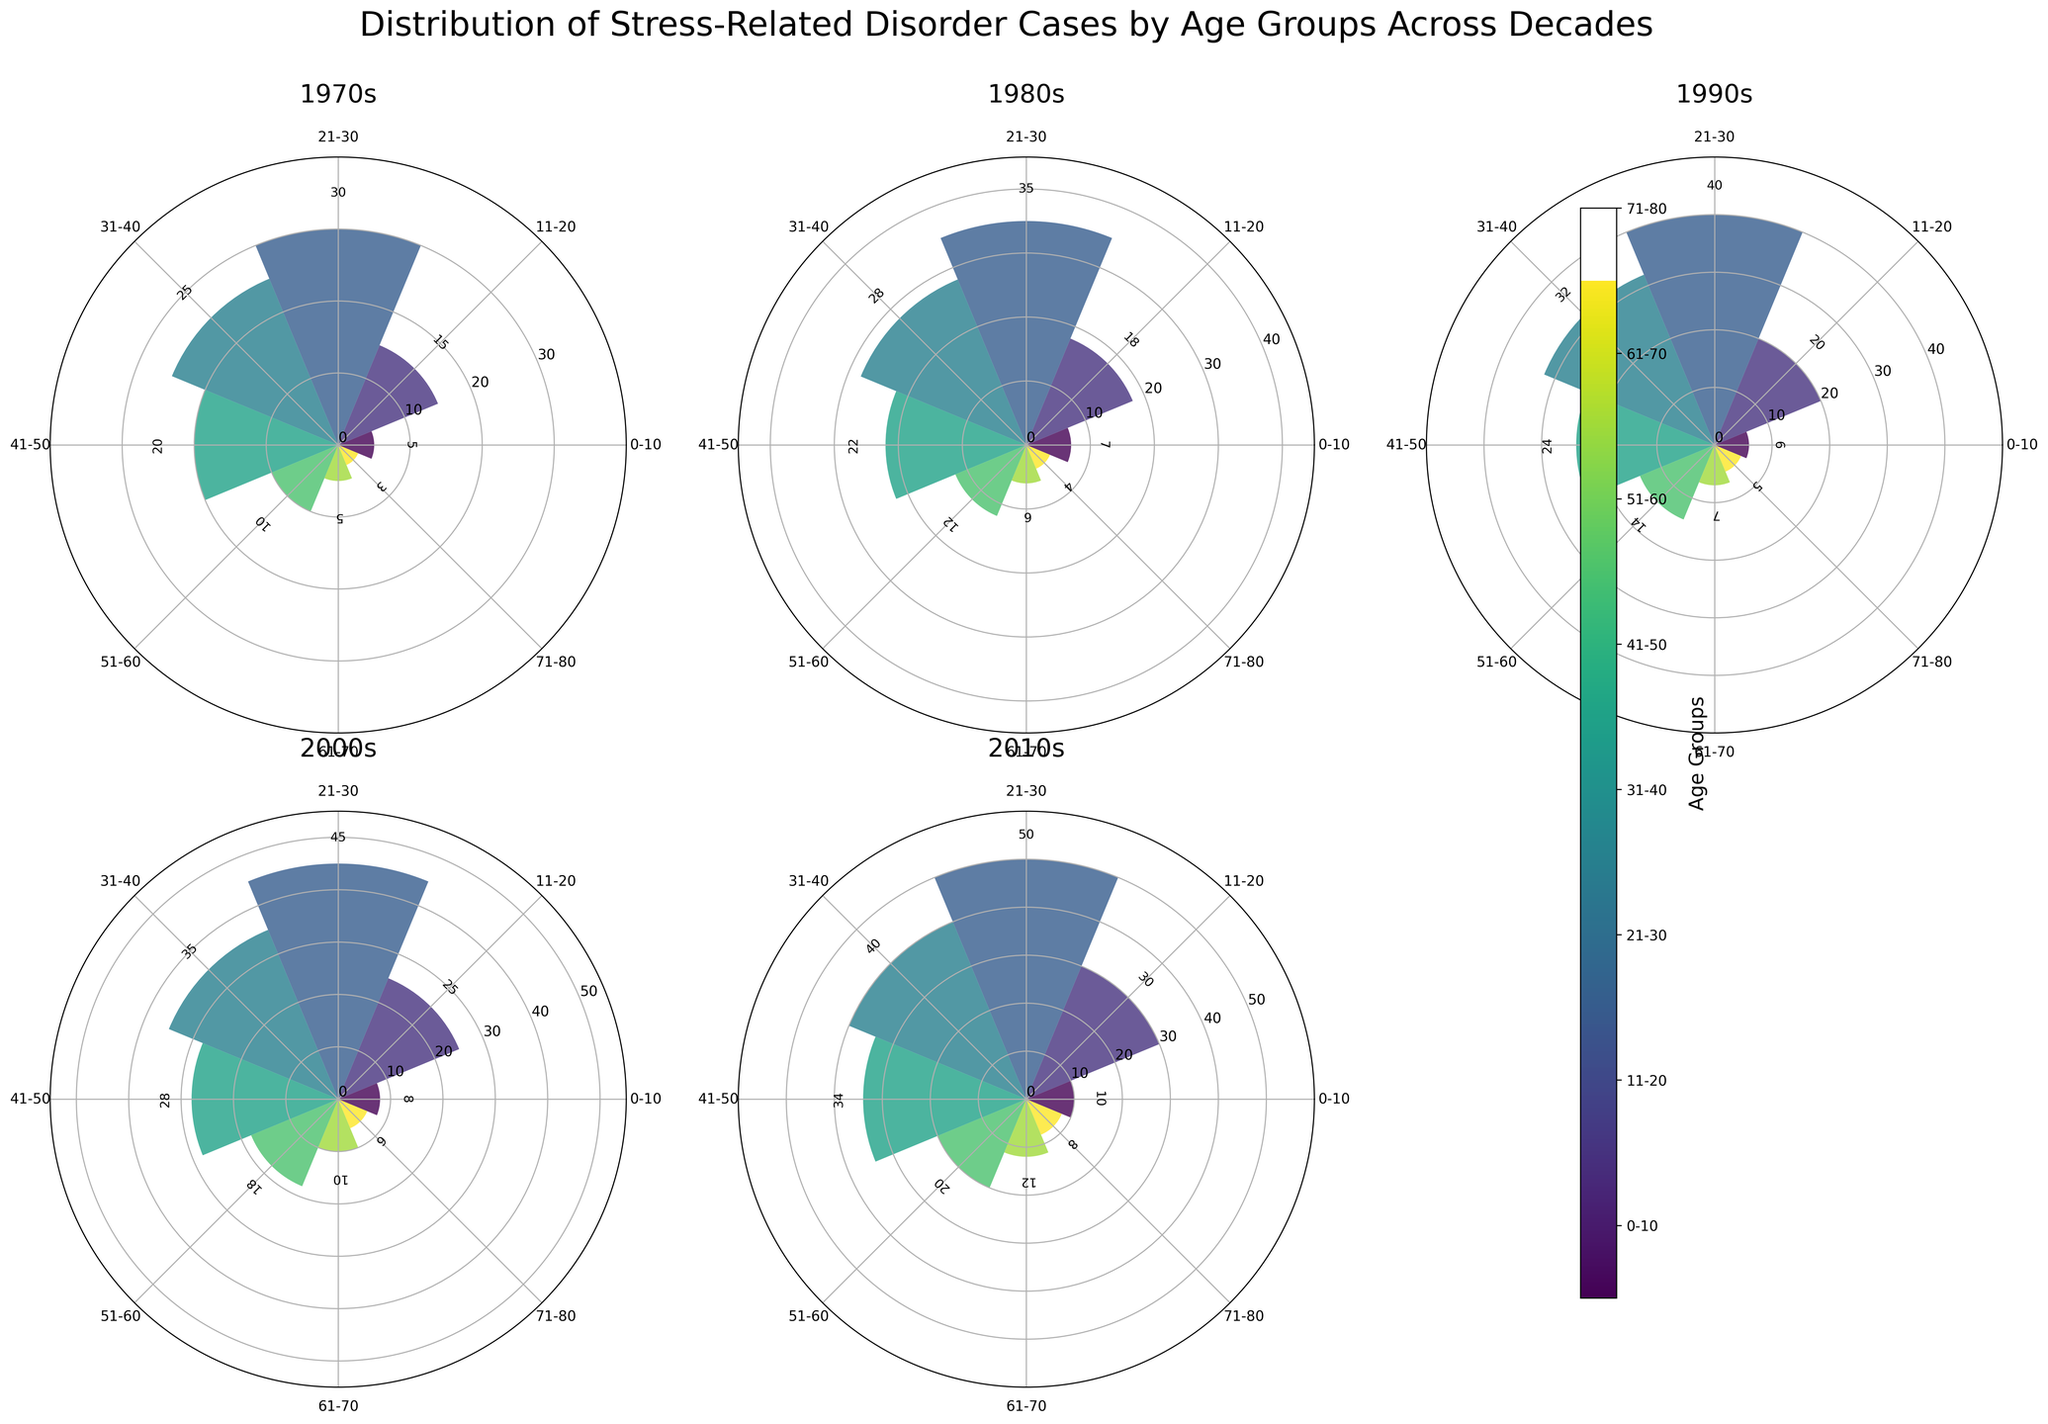What is the title of the figure? The title is usually placed at the top of the figure for easy identification. In this case, it describes the overall content.
Answer: Distribution of Stress-Related Disorder Cases by Age Groups Across Decades What colors are used in the figure to represent different age groups? Colors help differentiate between categories. Here, a gradient from the viridis colormap is utilized.
Answer: Various shades from viridis colormap (e.g., green to purple) Which decade shows the highest number of stress-related disorder cases for the age group 21-30? By comparing the heights of the bars in each subplot for the age group 21-30, we can identify the decade with the highest count.
Answer: 2010s What is the median number of stress-related disorder cases for the age group 31-40 across all decades? First, list the values for 31-40: [25, 28, 32, 35, 40]. Then, sort them and find the middle value.
Answer: 32 How does the distribution of cases in the 2010s compare to the 1970s for the age group 61-70? Comparing the height of the bars in the subplots for these two decades for age group 61-70 will show the difference.
Answer: Higher in the 2010s (12 vs. 5) Which decade exhibits the smallest variation in the number of cases across all age groups? Look at the subplots and identify the decade where the heights of the bars are closest to each other. Variation can be inferred visually by the uniformity of bar heights.
Answer: 1970s In which decade does the age group 11-20 have the fewest number of cases? By comparing the height of the bars corresponding to the age group 11-20 across subplots, we can find the decade with the smallest bar.
Answer: 1970s What was the total number of stress-related disorder cases reported in the 1980s? Sum all the values from the 1980s: 7+18+35+28+22+12+6+4 = 132.
Answer: 132 How does the trend in stress-related cases for the age group 0-10 evolve over the decades? Observe the change in bar heights for the age group 0-10 across the subplots to identify any trends.
Answer: Increases over the decades What does the bar representing the age group 71-80 in the 2000s indicate about the number of cases? Check the height and label of the bar for this group in the 2000s subplot.
Answer: 6 